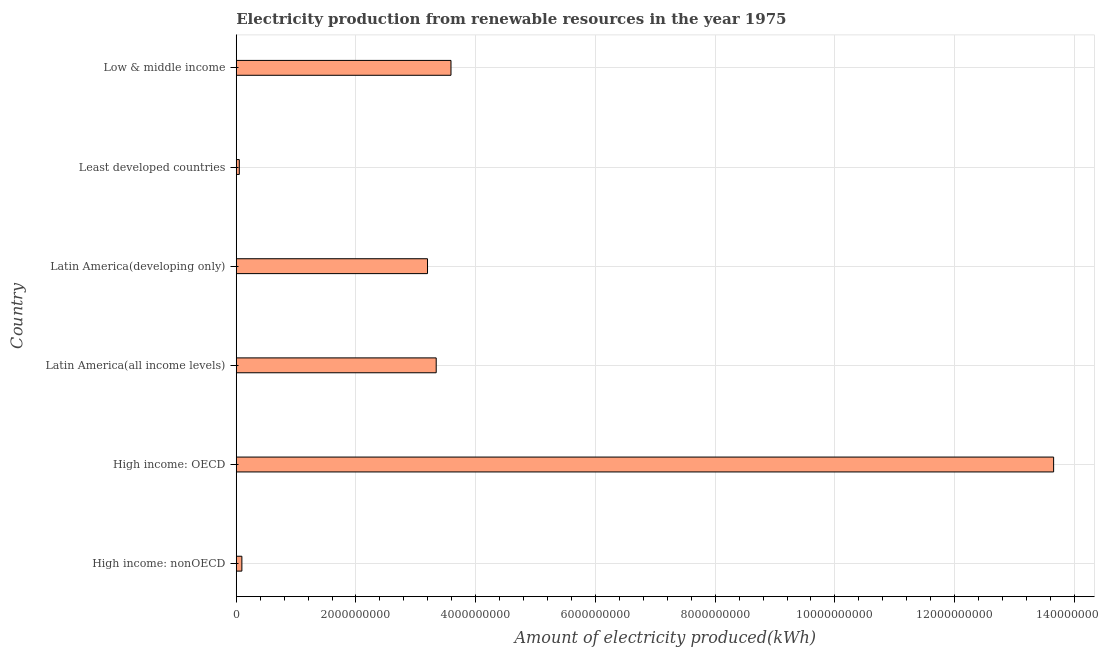Does the graph contain any zero values?
Keep it short and to the point. No. What is the title of the graph?
Your answer should be very brief. Electricity production from renewable resources in the year 1975. What is the label or title of the X-axis?
Ensure brevity in your answer.  Amount of electricity produced(kWh). What is the label or title of the Y-axis?
Provide a short and direct response. Country. What is the amount of electricity produced in Least developed countries?
Make the answer very short. 5.10e+07. Across all countries, what is the maximum amount of electricity produced?
Your answer should be very brief. 1.37e+1. Across all countries, what is the minimum amount of electricity produced?
Make the answer very short. 5.10e+07. In which country was the amount of electricity produced maximum?
Your response must be concise. High income: OECD. In which country was the amount of electricity produced minimum?
Provide a succinct answer. Least developed countries. What is the sum of the amount of electricity produced?
Offer a terse response. 2.39e+1. What is the difference between the amount of electricity produced in High income: OECD and Latin America(all income levels)?
Provide a succinct answer. 1.03e+1. What is the average amount of electricity produced per country?
Keep it short and to the point. 3.99e+09. What is the median amount of electricity produced?
Make the answer very short. 3.27e+09. In how many countries, is the amount of electricity produced greater than 10400000000 kWh?
Offer a very short reply. 1. What is the ratio of the amount of electricity produced in High income: OECD to that in Least developed countries?
Provide a succinct answer. 267.73. Is the difference between the amount of electricity produced in Latin America(developing only) and Least developed countries greater than the difference between any two countries?
Make the answer very short. No. What is the difference between the highest and the second highest amount of electricity produced?
Give a very brief answer. 1.01e+1. What is the difference between the highest and the lowest amount of electricity produced?
Provide a short and direct response. 1.36e+1. How many bars are there?
Ensure brevity in your answer.  6. How many countries are there in the graph?
Your answer should be compact. 6. Are the values on the major ticks of X-axis written in scientific E-notation?
Make the answer very short. No. What is the Amount of electricity produced(kWh) in High income: nonOECD?
Offer a terse response. 9.40e+07. What is the Amount of electricity produced(kWh) in High income: OECD?
Give a very brief answer. 1.37e+1. What is the Amount of electricity produced(kWh) of Latin America(all income levels)?
Your answer should be very brief. 3.34e+09. What is the Amount of electricity produced(kWh) in Latin America(developing only)?
Your answer should be very brief. 3.20e+09. What is the Amount of electricity produced(kWh) in Least developed countries?
Provide a succinct answer. 5.10e+07. What is the Amount of electricity produced(kWh) in Low & middle income?
Provide a succinct answer. 3.59e+09. What is the difference between the Amount of electricity produced(kWh) in High income: nonOECD and High income: OECD?
Offer a very short reply. -1.36e+1. What is the difference between the Amount of electricity produced(kWh) in High income: nonOECD and Latin America(all income levels)?
Make the answer very short. -3.25e+09. What is the difference between the Amount of electricity produced(kWh) in High income: nonOECD and Latin America(developing only)?
Provide a succinct answer. -3.10e+09. What is the difference between the Amount of electricity produced(kWh) in High income: nonOECD and Least developed countries?
Ensure brevity in your answer.  4.30e+07. What is the difference between the Amount of electricity produced(kWh) in High income: nonOECD and Low & middle income?
Your answer should be very brief. -3.49e+09. What is the difference between the Amount of electricity produced(kWh) in High income: OECD and Latin America(all income levels)?
Make the answer very short. 1.03e+1. What is the difference between the Amount of electricity produced(kWh) in High income: OECD and Latin America(developing only)?
Keep it short and to the point. 1.05e+1. What is the difference between the Amount of electricity produced(kWh) in High income: OECD and Least developed countries?
Provide a succinct answer. 1.36e+1. What is the difference between the Amount of electricity produced(kWh) in High income: OECD and Low & middle income?
Provide a short and direct response. 1.01e+1. What is the difference between the Amount of electricity produced(kWh) in Latin America(all income levels) and Latin America(developing only)?
Your response must be concise. 1.45e+08. What is the difference between the Amount of electricity produced(kWh) in Latin America(all income levels) and Least developed countries?
Provide a succinct answer. 3.29e+09. What is the difference between the Amount of electricity produced(kWh) in Latin America(all income levels) and Low & middle income?
Your answer should be very brief. -2.47e+08. What is the difference between the Amount of electricity produced(kWh) in Latin America(developing only) and Least developed countries?
Offer a terse response. 3.14e+09. What is the difference between the Amount of electricity produced(kWh) in Latin America(developing only) and Low & middle income?
Offer a very short reply. -3.92e+08. What is the difference between the Amount of electricity produced(kWh) in Least developed countries and Low & middle income?
Offer a terse response. -3.54e+09. What is the ratio of the Amount of electricity produced(kWh) in High income: nonOECD to that in High income: OECD?
Your response must be concise. 0.01. What is the ratio of the Amount of electricity produced(kWh) in High income: nonOECD to that in Latin America(all income levels)?
Your response must be concise. 0.03. What is the ratio of the Amount of electricity produced(kWh) in High income: nonOECD to that in Latin America(developing only)?
Provide a succinct answer. 0.03. What is the ratio of the Amount of electricity produced(kWh) in High income: nonOECD to that in Least developed countries?
Provide a short and direct response. 1.84. What is the ratio of the Amount of electricity produced(kWh) in High income: nonOECD to that in Low & middle income?
Make the answer very short. 0.03. What is the ratio of the Amount of electricity produced(kWh) in High income: OECD to that in Latin America(all income levels)?
Your response must be concise. 4.09. What is the ratio of the Amount of electricity produced(kWh) in High income: OECD to that in Latin America(developing only)?
Give a very brief answer. 4.27. What is the ratio of the Amount of electricity produced(kWh) in High income: OECD to that in Least developed countries?
Your answer should be very brief. 267.73. What is the ratio of the Amount of electricity produced(kWh) in High income: OECD to that in Low & middle income?
Offer a very short reply. 3.81. What is the ratio of the Amount of electricity produced(kWh) in Latin America(all income levels) to that in Latin America(developing only)?
Your response must be concise. 1.04. What is the ratio of the Amount of electricity produced(kWh) in Latin America(all income levels) to that in Least developed countries?
Give a very brief answer. 65.49. What is the ratio of the Amount of electricity produced(kWh) in Latin America(developing only) to that in Least developed countries?
Offer a terse response. 62.65. What is the ratio of the Amount of electricity produced(kWh) in Latin America(developing only) to that in Low & middle income?
Offer a very short reply. 0.89. What is the ratio of the Amount of electricity produced(kWh) in Least developed countries to that in Low & middle income?
Your answer should be compact. 0.01. 